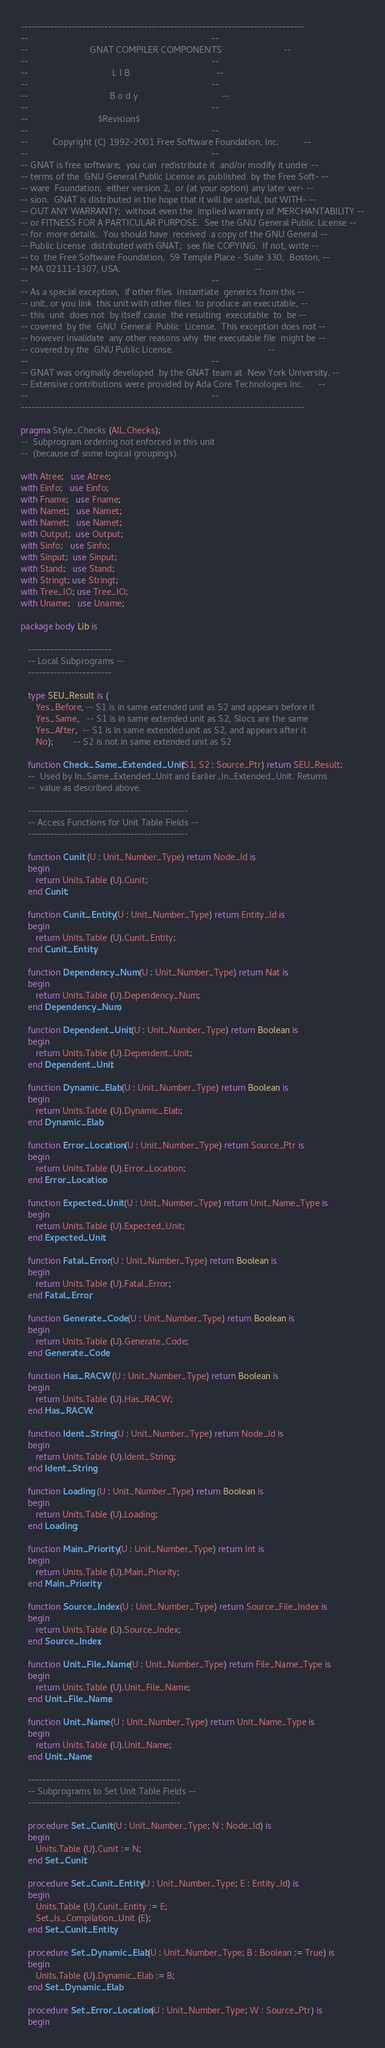Convert code to text. <code><loc_0><loc_0><loc_500><loc_500><_Ada_>------------------------------------------------------------------------------
--                                                                          --
--                         GNAT COMPILER COMPONENTS                         --
--                                                                          --
--                                  L I B                                   --
--                                                                          --
--                                 B o d y                                  --
--                                                                          --
--                            $Revision$
--                                                                          --
--          Copyright (C) 1992-2001 Free Software Foundation, Inc.          --
--                                                                          --
-- GNAT is free software;  you can  redistribute it  and/or modify it under --
-- terms of the  GNU General Public License as published  by the Free Soft- --
-- ware  Foundation;  either version 2,  or (at your option) any later ver- --
-- sion.  GNAT is distributed in the hope that it will be useful, but WITH- --
-- OUT ANY WARRANTY;  without even the  implied warranty of MERCHANTABILITY --
-- or FITNESS FOR A PARTICULAR PURPOSE.  See the GNU General Public License --
-- for  more details.  You should have  received  a copy of the GNU General --
-- Public License  distributed with GNAT;  see file COPYING.  If not, write --
-- to  the Free Software Foundation,  59 Temple Place - Suite 330,  Boston, --
-- MA 02111-1307, USA.                                                      --
--                                                                          --
-- As a special exception,  if other files  instantiate  generics from this --
-- unit, or you link  this unit with other files  to produce an executable, --
-- this  unit  does not  by itself cause  the resulting  executable  to  be --
-- covered  by the  GNU  General  Public  License.  This exception does not --
-- however invalidate  any other reasons why  the executable file  might be --
-- covered by the  GNU Public License.                                      --
--                                                                          --
-- GNAT was originally developed  by the GNAT team at  New York University. --
-- Extensive contributions were provided by Ada Core Technologies Inc.      --
--                                                                          --
------------------------------------------------------------------------------

pragma Style_Checks (All_Checks);
--  Subprogram ordering not enforced in this unit
--  (because of some logical groupings).

with Atree;   use Atree;
with Einfo;   use Einfo;
with Fname;   use Fname;
with Namet;   use Namet;
with Namet;   use Namet;
with Output;  use Output;
with Sinfo;   use Sinfo;
with Sinput;  use Sinput;
with Stand;   use Stand;
with Stringt; use Stringt;
with Tree_IO; use Tree_IO;
with Uname;   use Uname;

package body Lib is

   -----------------------
   -- Local Subprograms --
   -----------------------

   type SEU_Result is (
      Yes_Before, -- S1 is in same extended unit as S2 and appears before it
      Yes_Same,   -- S1 is in same extended unit as S2, Slocs are the same
      Yes_After,  -- S1 is in same extended unit as S2, and appears after it
      No);        -- S2 is not in same extended unit as S2

   function Check_Same_Extended_Unit (S1, S2 : Source_Ptr) return SEU_Result;
   --  Used by In_Same_Extended_Unit and Earlier_In_Extended_Unit. Returns
   --  value as described above.

   --------------------------------------------
   -- Access Functions for Unit Table Fields --
   --------------------------------------------

   function Cunit (U : Unit_Number_Type) return Node_Id is
   begin
      return Units.Table (U).Cunit;
   end Cunit;

   function Cunit_Entity (U : Unit_Number_Type) return Entity_Id is
   begin
      return Units.Table (U).Cunit_Entity;
   end Cunit_Entity;

   function Dependency_Num (U : Unit_Number_Type) return Nat is
   begin
      return Units.Table (U).Dependency_Num;
   end Dependency_Num;

   function Dependent_Unit (U : Unit_Number_Type) return Boolean is
   begin
      return Units.Table (U).Dependent_Unit;
   end Dependent_Unit;

   function Dynamic_Elab (U : Unit_Number_Type) return Boolean is
   begin
      return Units.Table (U).Dynamic_Elab;
   end Dynamic_Elab;

   function Error_Location (U : Unit_Number_Type) return Source_Ptr is
   begin
      return Units.Table (U).Error_Location;
   end Error_Location;

   function Expected_Unit (U : Unit_Number_Type) return Unit_Name_Type is
   begin
      return Units.Table (U).Expected_Unit;
   end Expected_Unit;

   function Fatal_Error (U : Unit_Number_Type) return Boolean is
   begin
      return Units.Table (U).Fatal_Error;
   end Fatal_Error;

   function Generate_Code (U : Unit_Number_Type) return Boolean is
   begin
      return Units.Table (U).Generate_Code;
   end Generate_Code;

   function Has_RACW (U : Unit_Number_Type) return Boolean is
   begin
      return Units.Table (U).Has_RACW;
   end Has_RACW;

   function Ident_String (U : Unit_Number_Type) return Node_Id is
   begin
      return Units.Table (U).Ident_String;
   end Ident_String;

   function Loading (U : Unit_Number_Type) return Boolean is
   begin
      return Units.Table (U).Loading;
   end Loading;

   function Main_Priority (U : Unit_Number_Type) return Int is
   begin
      return Units.Table (U).Main_Priority;
   end Main_Priority;

   function Source_Index (U : Unit_Number_Type) return Source_File_Index is
   begin
      return Units.Table (U).Source_Index;
   end Source_Index;

   function Unit_File_Name (U : Unit_Number_Type) return File_Name_Type is
   begin
      return Units.Table (U).Unit_File_Name;
   end Unit_File_Name;

   function Unit_Name (U : Unit_Number_Type) return Unit_Name_Type is
   begin
      return Units.Table (U).Unit_Name;
   end Unit_Name;

   ------------------------------------------
   -- Subprograms to Set Unit Table Fields --
   ------------------------------------------

   procedure Set_Cunit (U : Unit_Number_Type; N : Node_Id) is
   begin
      Units.Table (U).Cunit := N;
   end Set_Cunit;

   procedure Set_Cunit_Entity (U : Unit_Number_Type; E : Entity_Id) is
   begin
      Units.Table (U).Cunit_Entity := E;
      Set_Is_Compilation_Unit (E);
   end Set_Cunit_Entity;

   procedure Set_Dynamic_Elab (U : Unit_Number_Type; B : Boolean := True) is
   begin
      Units.Table (U).Dynamic_Elab := B;
   end Set_Dynamic_Elab;

   procedure Set_Error_Location (U : Unit_Number_Type; W : Source_Ptr) is
   begin</code> 